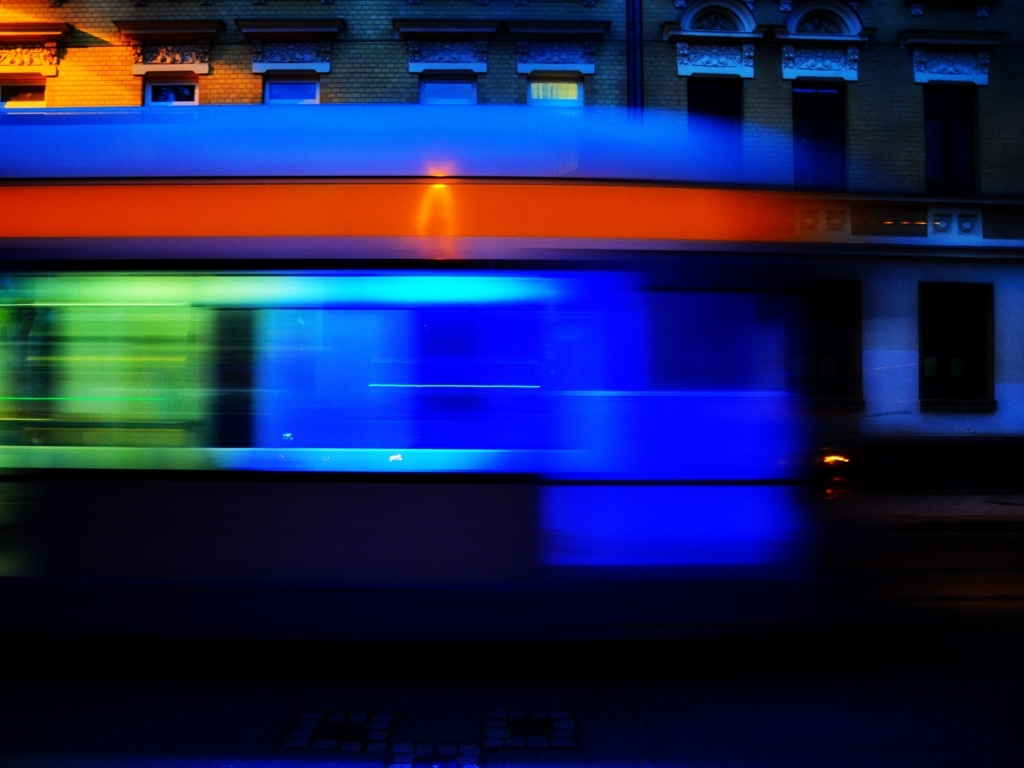Is the image of good quality? While there are subjective aspects to image quality, the photograph does exhibit clear intention with its use of motion blur to convey movement, and the colors are vibrant and well-captured. However, some may consider the slight lack of sharpness and the abstractness as factors that could be improved for certain purposes. This aesthetic is not universally 'good quality', but it has artistic merit. 